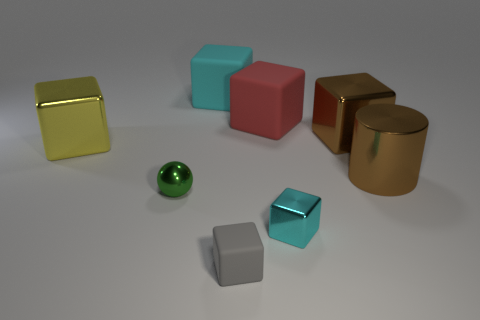Which object stands out the most to you and why? The object that stands out the most is the shiny gold cube. Its reflective surface catches the light, making it a dominant visual element in the composition. Compared to the matte textures and softer hues of the other items, the gold cube draws the eye with its brightness and reflective quality. 